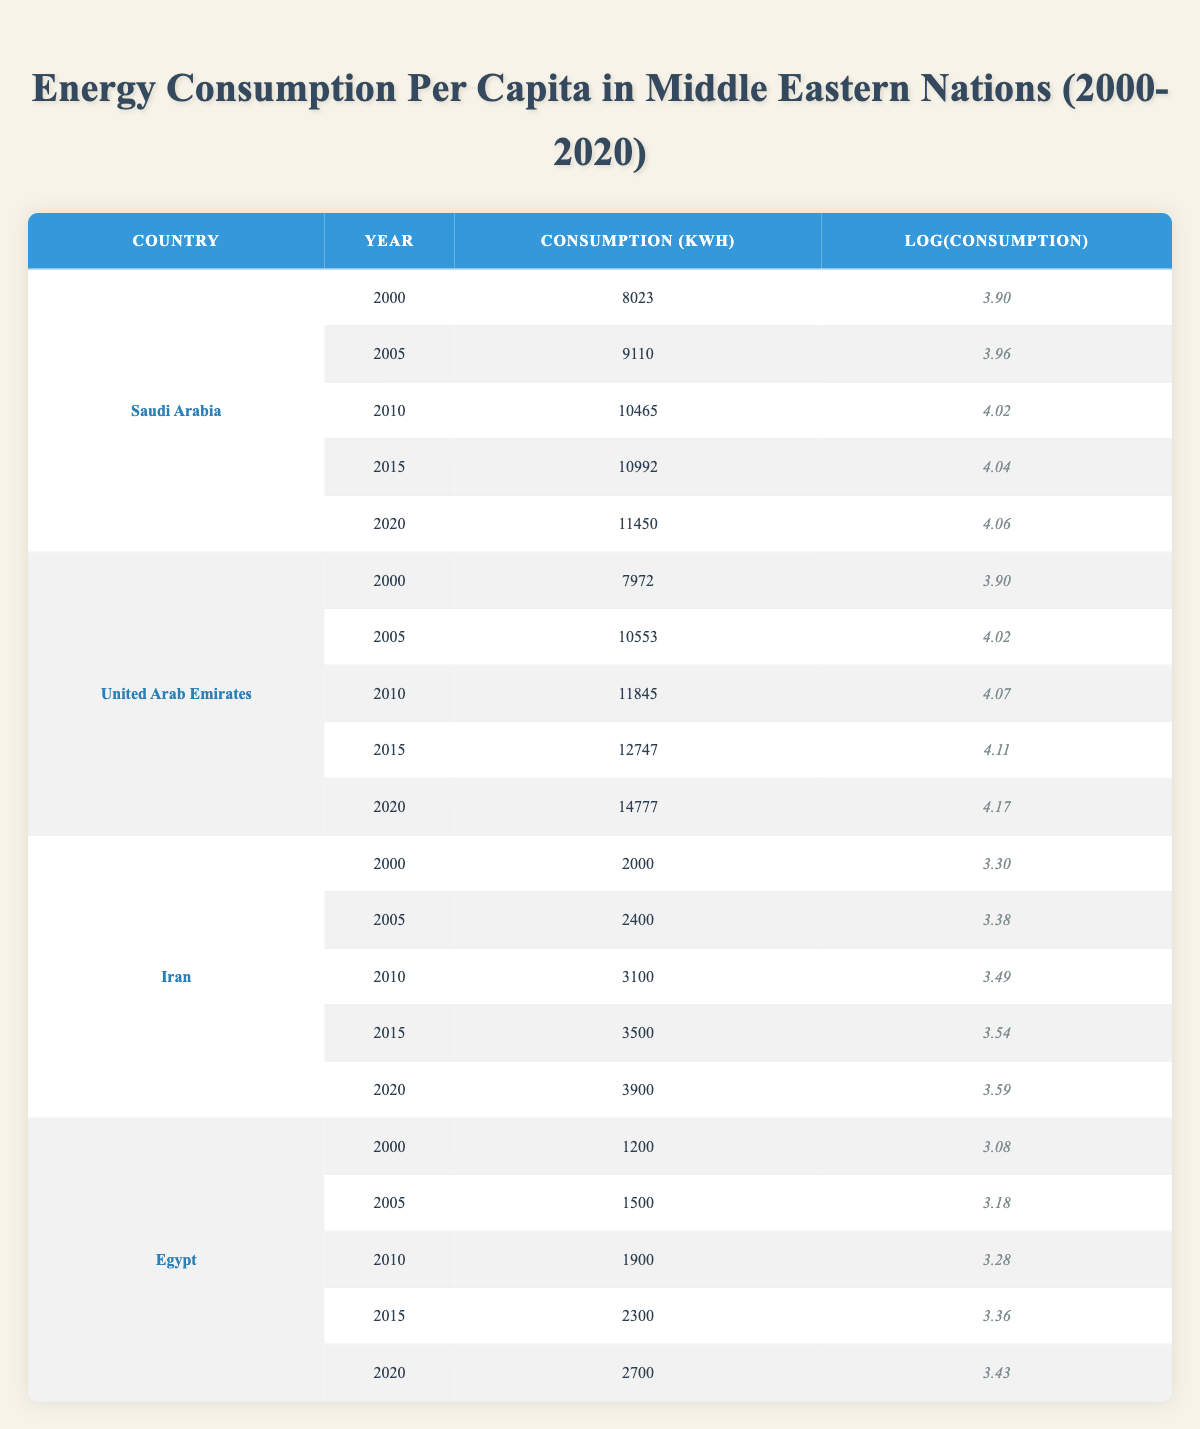What was the energy consumption per capita in Saudi Arabia in 2010? The table shows that in 2010, Saudi Arabia had a consumption of 10465 kWh.
Answer: 10465 kWh What is the logarithmic value of energy consumption in the United Arab Emirates in 2020? According to the table, the log value for the energy consumption in the United Arab Emirates in 2020 is 4.17.
Answer: 4.17 Did Iran have higher energy consumption per capita than Egypt in 2015? In 2015, Iran had a consumption of 3500 kWh, while Egypt had a consumption of 2300 kWh. Since 3500 > 2300, the statement is true.
Answer: Yes What is the average energy consumption per capita for Egypt from 2000 to 2020? The sum of Egypt's energy consumption values from 2000 to 2020 is 1200 + 1500 + 1900 + 2300 + 2700 = 11600 kWh. There are 5 data points, so the average is calculated as 11600 / 5 = 2320 kWh.
Answer: 2320 kWh Which country had the lowest energy consumption per capita in 2000? In 2000, Egypt had the lowest consumption at 1200 kWh, while other countries listed had higher values.
Answer: Egypt 